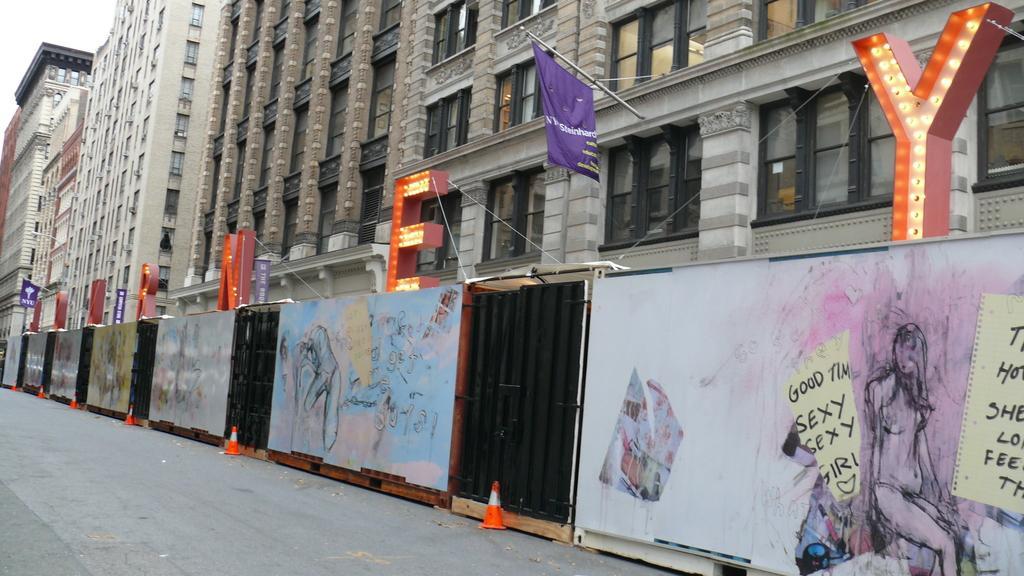Could you give a brief overview of what you see in this image? In this image I can see there are paintings on this wall. There are buildings on the right side, in the middle there is the flag in brinjal color. There is the name with the lights. 